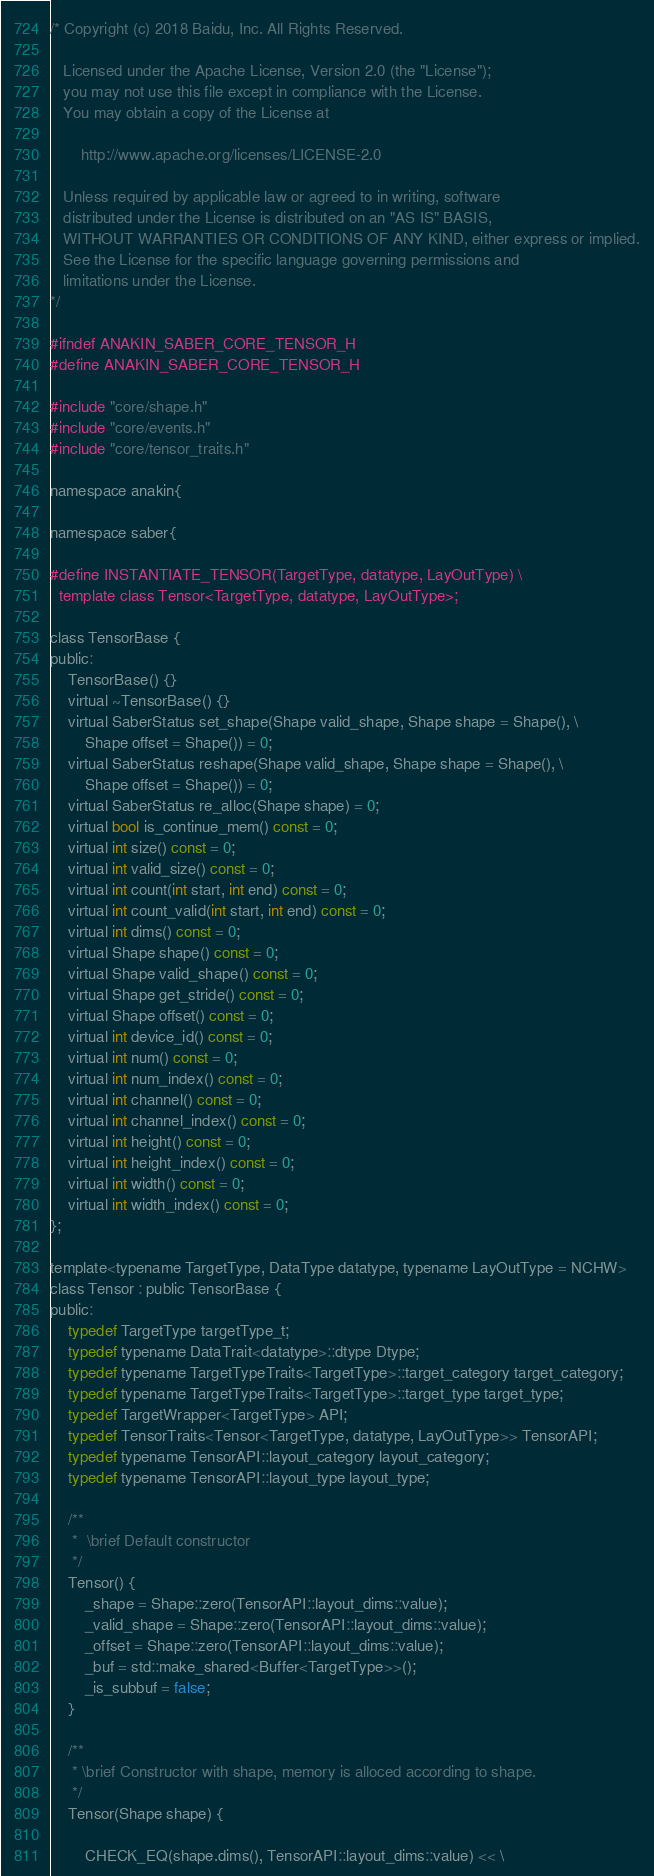Convert code to text. <code><loc_0><loc_0><loc_500><loc_500><_C_>/* Copyright (c) 2018 Baidu, Inc. All Rights Reserved.

   Licensed under the Apache License, Version 2.0 (the "License");
   you may not use this file except in compliance with the License.
   You may obtain a copy of the License at

       http://www.apache.org/licenses/LICENSE-2.0

   Unless required by applicable law or agreed to in writing, software
   distributed under the License is distributed on an "AS IS" BASIS,
   WITHOUT WARRANTIES OR CONDITIONS OF ANY KIND, either express or implied.
   See the License for the specific language governing permissions and
   limitations under the License.
*/

#ifndef ANAKIN_SABER_CORE_TENSOR_H
#define ANAKIN_SABER_CORE_TENSOR_H

#include "core/shape.h"
#include "core/events.h"
#include "core/tensor_traits.h"

namespace anakin{

namespace saber{

#define INSTANTIATE_TENSOR(TargetType, datatype, LayOutType) \
  template class Tensor<TargetType, datatype, LayOutType>;

class TensorBase {
public:
    TensorBase() {}
    virtual ~TensorBase() {}
    virtual SaberStatus set_shape(Shape valid_shape, Shape shape = Shape(), \
        Shape offset = Shape()) = 0;
    virtual SaberStatus reshape(Shape valid_shape, Shape shape = Shape(), \
        Shape offset = Shape()) = 0;
    virtual SaberStatus re_alloc(Shape shape) = 0;
    virtual bool is_continue_mem() const = 0;
    virtual int size() const = 0;
    virtual int valid_size() const = 0;
    virtual int count(int start, int end) const = 0;
    virtual int count_valid(int start, int end) const = 0;
    virtual int dims() const = 0;
    virtual Shape shape() const = 0;
    virtual Shape valid_shape() const = 0;
    virtual Shape get_stride() const = 0;
    virtual Shape offset() const = 0;
    virtual int device_id() const = 0;
    virtual int num() const = 0;
    virtual int num_index() const = 0;
    virtual int channel() const = 0;
    virtual int channel_index() const = 0;
    virtual int height() const = 0;
    virtual int height_index() const = 0;
    virtual int width() const = 0;
    virtual int width_index() const = 0;
};

template<typename TargetType, DataType datatype, typename LayOutType = NCHW>
class Tensor : public TensorBase {
public:
    typedef TargetType targetType_t;
    typedef typename DataTrait<datatype>::dtype Dtype;
    typedef typename TargetTypeTraits<TargetType>::target_category target_category;
    typedef typename TargetTypeTraits<TargetType>::target_type target_type;
    typedef TargetWrapper<TargetType> API;
    typedef TensorTraits<Tensor<TargetType, datatype, LayOutType>> TensorAPI;
    typedef typename TensorAPI::layout_category layout_category;
    typedef typename TensorAPI::layout_type layout_type;

    /**
     *  \brief Default constructor
     */
    Tensor() {
        _shape = Shape::zero(TensorAPI::layout_dims::value);
        _valid_shape = Shape::zero(TensorAPI::layout_dims::value);
        _offset = Shape::zero(TensorAPI::layout_dims::value);
        _buf = std::make_shared<Buffer<TargetType>>();
        _is_subbuf = false;
    }

    /**
     * \brief Constructor with shape, memory is alloced according to shape.
     */
    Tensor(Shape shape) {

        CHECK_EQ(shape.dims(), TensorAPI::layout_dims::value) << \</code> 